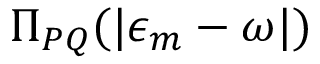<formula> <loc_0><loc_0><loc_500><loc_500>\Pi _ { P Q } ( | \epsilon _ { m } - \omega | )</formula> 